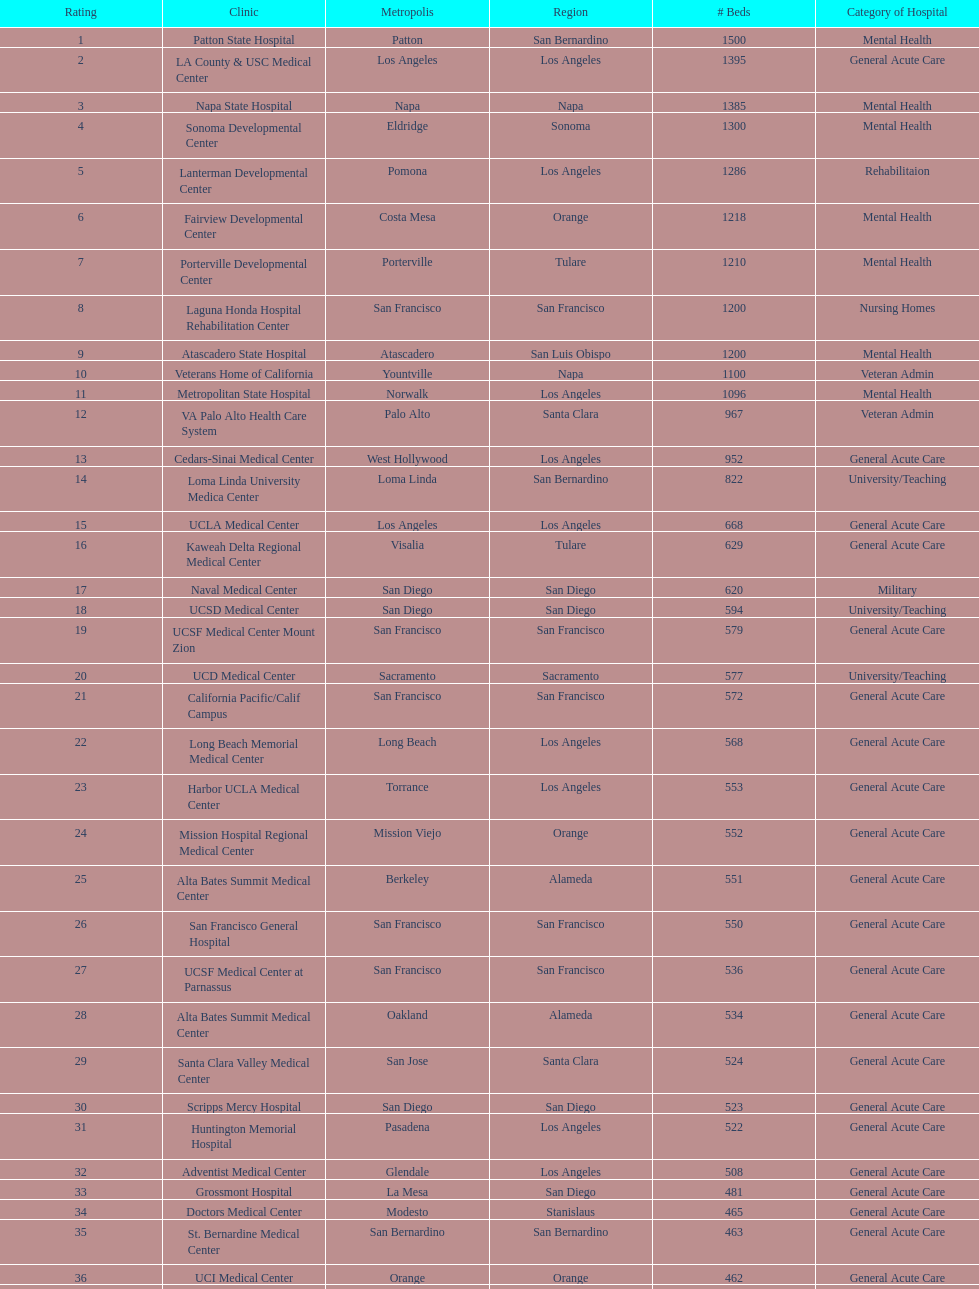Which type of hospitals are the same as grossmont hospital? General Acute Care. 